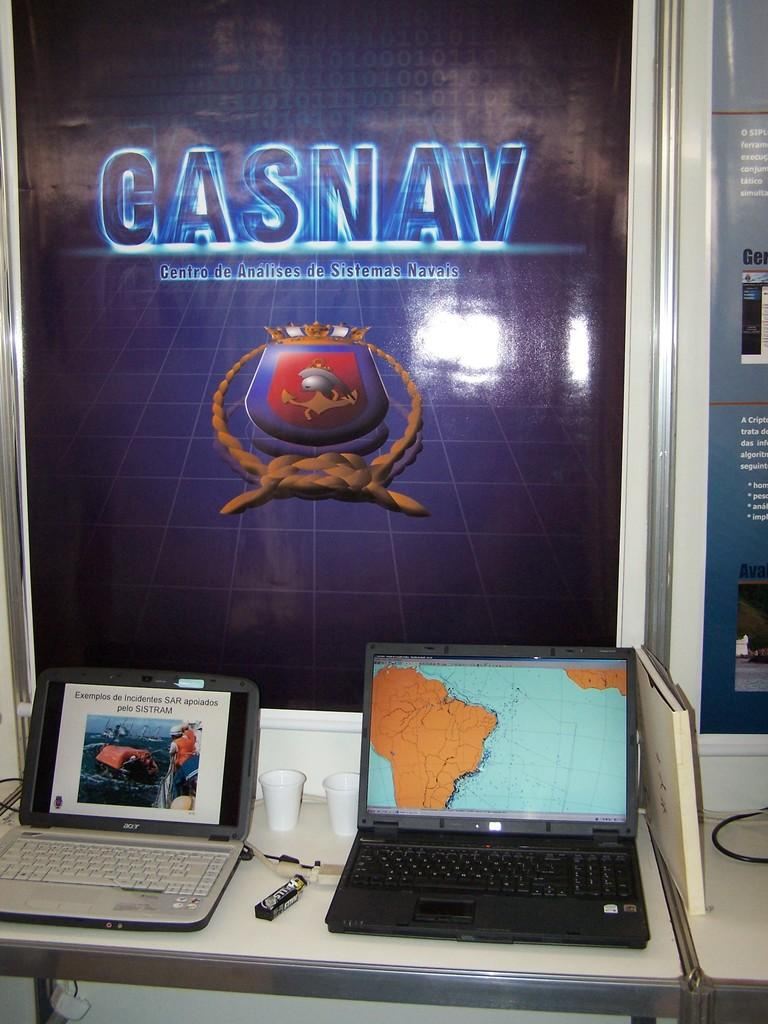<image>
Render a clear and concise summary of the photo. Two laptops are sitting underneath a large Gasnav poster. 